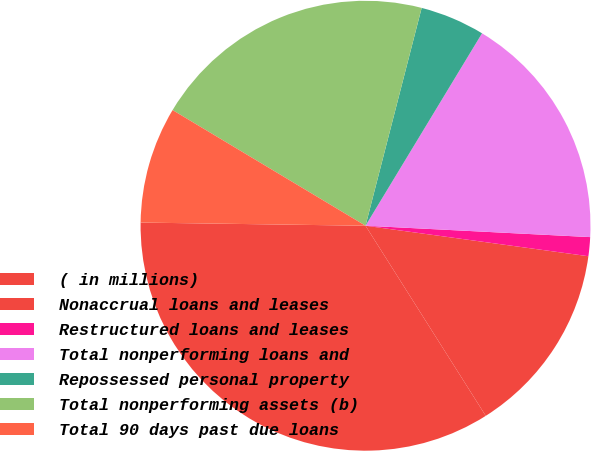Convert chart. <chart><loc_0><loc_0><loc_500><loc_500><pie_chart><fcel>( in millions)<fcel>Nonaccrual loans and leases<fcel>Restructured loans and leases<fcel>Total nonperforming loans and<fcel>Repossessed personal property<fcel>Total nonperforming assets (b)<fcel>Total 90 days past due loans<nl><fcel>34.2%<fcel>13.86%<fcel>1.36%<fcel>17.14%<fcel>4.65%<fcel>20.42%<fcel>8.37%<nl></chart> 